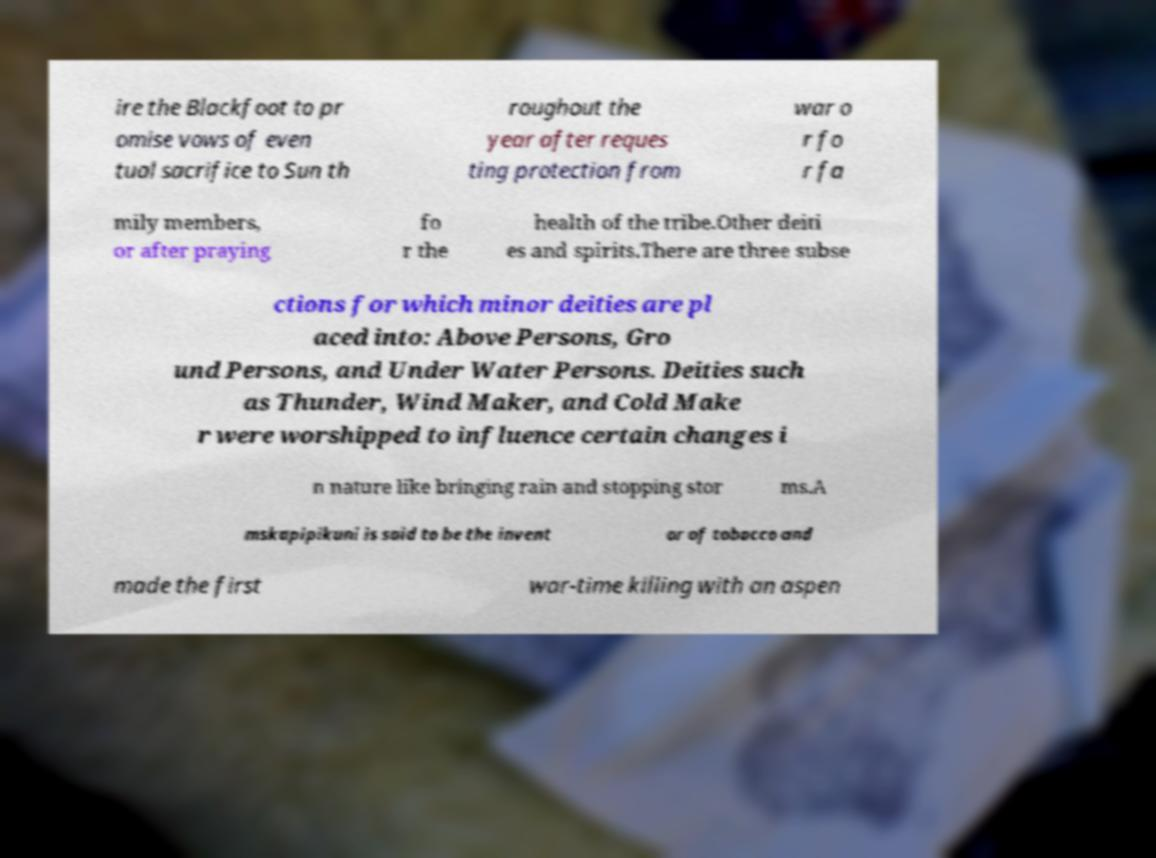Could you assist in decoding the text presented in this image and type it out clearly? ire the Blackfoot to pr omise vows of even tual sacrifice to Sun th roughout the year after reques ting protection from war o r fo r fa mily members, or after praying fo r the health of the tribe.Other deiti es and spirits.There are three subse ctions for which minor deities are pl aced into: Above Persons, Gro und Persons, and Under Water Persons. Deities such as Thunder, Wind Maker, and Cold Make r were worshipped to influence certain changes i n nature like bringing rain and stopping stor ms.A mskapipikuni is said to be the invent or of tobacco and made the first war-time killing with an aspen 